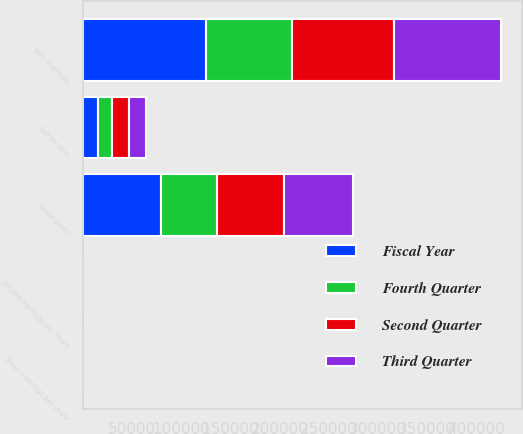<chart> <loc_0><loc_0><loc_500><loc_500><stacked_bar_chart><ecel><fcel>Net revenues<fcel>Gross profit<fcel>Net income<fcel>Basic earnings per share<fcel>Diluted earnings per share<nl><fcel>Fourth Quarter<fcel>87733<fcel>56411<fcel>13926<fcel>0.21<fcel>0.2<nl><fcel>Second Quarter<fcel>103893<fcel>68378<fcel>17404<fcel>0.26<fcel>0.25<nl><fcel>Third Quarter<fcel>108454<fcel>70295<fcel>17877<fcel>0.26<fcel>0.25<nl><fcel>Fiscal Year<fcel>125425<fcel>79776<fcel>15578<fcel>0.22<fcel>0.22<nl></chart> 